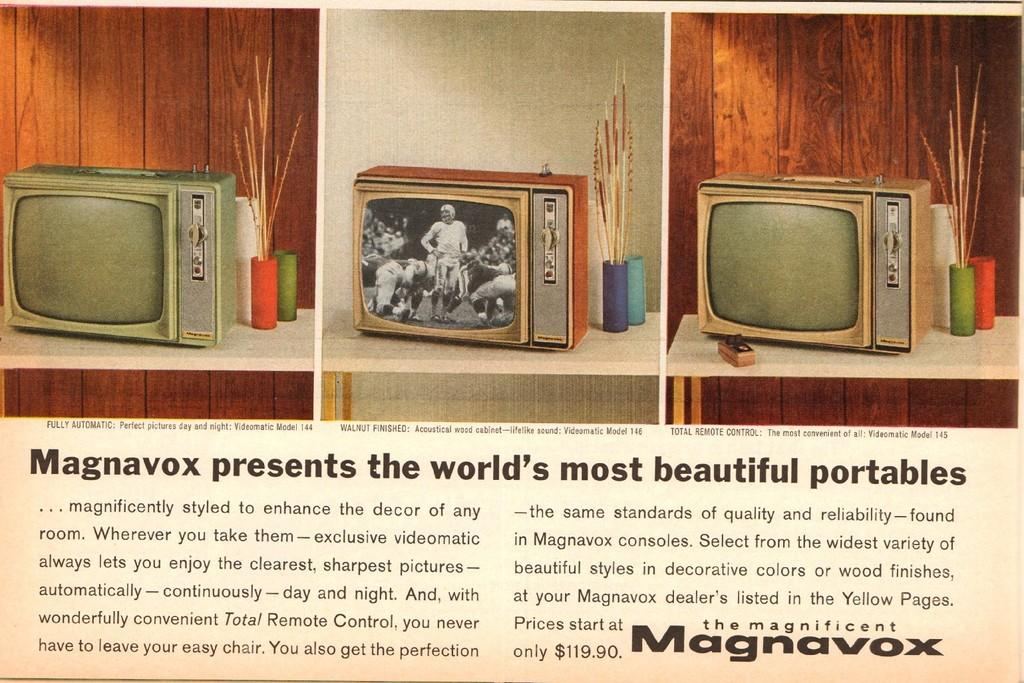<image>
Write a terse but informative summary of the picture. An old article about the magnificent Magnavox portables. 